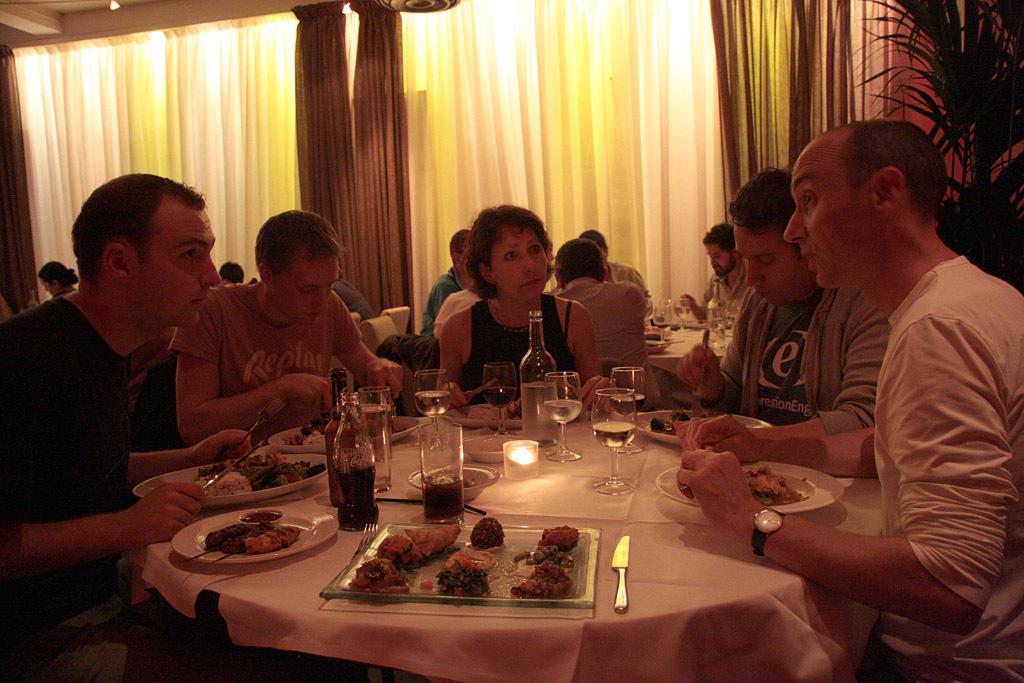Please provide a concise description of this image. There are so many people sitting around a table eating food in the place and there are glasses with the wine and a bottle behind them there is a curtain and plant. 